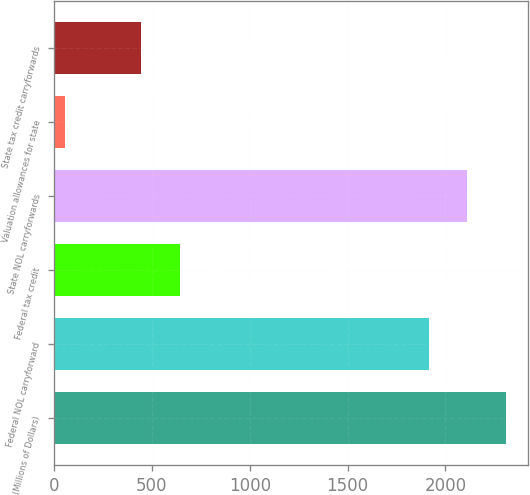Convert chart. <chart><loc_0><loc_0><loc_500><loc_500><bar_chart><fcel>(Millions of Dollars)<fcel>Federal NOL carryforward<fcel>Federal tax credit<fcel>State NOL carryforwards<fcel>Valuation allowances for state<fcel>State tax credit carryforwards<nl><fcel>2308.4<fcel>1916<fcel>642.6<fcel>2112.2<fcel>54<fcel>446.4<nl></chart> 